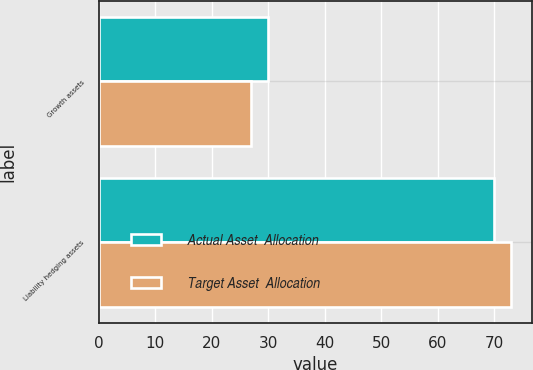Convert chart to OTSL. <chart><loc_0><loc_0><loc_500><loc_500><stacked_bar_chart><ecel><fcel>Growth assets<fcel>Liability hedging assets<nl><fcel>Actual Asset  Allocation<fcel>30<fcel>70<nl><fcel>Target Asset  Allocation<fcel>27<fcel>73<nl></chart> 